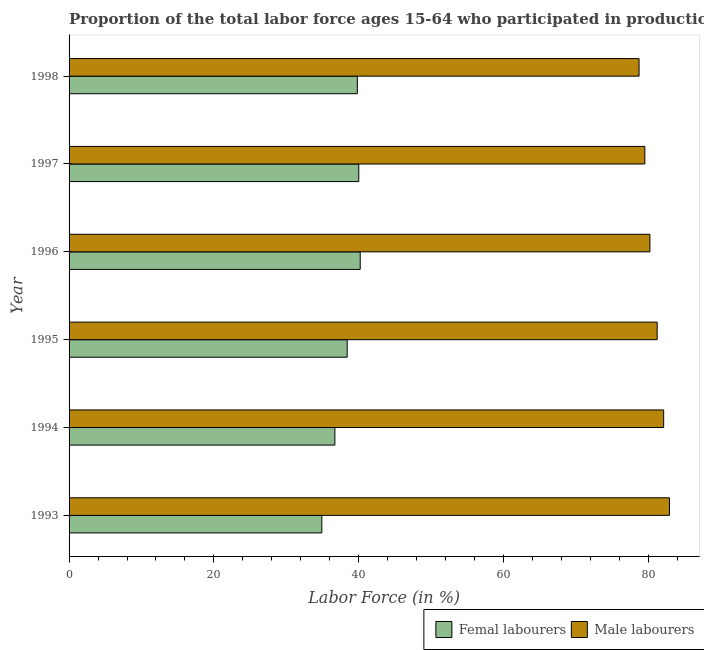How many groups of bars are there?
Your response must be concise. 6. Are the number of bars per tick equal to the number of legend labels?
Offer a very short reply. Yes. Are the number of bars on each tick of the Y-axis equal?
Your answer should be very brief. Yes. How many bars are there on the 2nd tick from the top?
Offer a very short reply. 2. What is the percentage of female labor force in 1996?
Give a very brief answer. 40.2. Across all years, what is the maximum percentage of male labour force?
Offer a terse response. 82.9. Across all years, what is the minimum percentage of female labor force?
Keep it short and to the point. 34.9. In which year was the percentage of female labor force maximum?
Offer a terse response. 1996. What is the total percentage of female labor force in the graph?
Ensure brevity in your answer.  230. What is the difference between the percentage of female labor force in 1994 and that in 1997?
Make the answer very short. -3.3. What is the difference between the percentage of female labor force in 1998 and the percentage of male labour force in 1995?
Provide a short and direct response. -41.4. What is the average percentage of male labour force per year?
Make the answer very short. 80.77. In the year 1997, what is the difference between the percentage of male labour force and percentage of female labor force?
Ensure brevity in your answer.  39.5. In how many years, is the percentage of female labor force greater than 72 %?
Ensure brevity in your answer.  0. What is the ratio of the percentage of female labor force in 1993 to that in 1996?
Your answer should be very brief. 0.87. What is the difference between the highest and the lowest percentage of female labor force?
Your answer should be compact. 5.3. In how many years, is the percentage of female labor force greater than the average percentage of female labor force taken over all years?
Your response must be concise. 4. Is the sum of the percentage of male labour force in 1997 and 1998 greater than the maximum percentage of female labor force across all years?
Provide a short and direct response. Yes. What does the 2nd bar from the top in 1998 represents?
Provide a short and direct response. Femal labourers. What does the 2nd bar from the bottom in 1997 represents?
Provide a short and direct response. Male labourers. How many years are there in the graph?
Offer a very short reply. 6. What is the difference between two consecutive major ticks on the X-axis?
Your response must be concise. 20. Are the values on the major ticks of X-axis written in scientific E-notation?
Ensure brevity in your answer.  No. What is the title of the graph?
Offer a terse response. Proportion of the total labor force ages 15-64 who participated in production in Fiji. What is the label or title of the X-axis?
Your answer should be compact. Labor Force (in %). What is the label or title of the Y-axis?
Provide a succinct answer. Year. What is the Labor Force (in %) of Femal labourers in 1993?
Keep it short and to the point. 34.9. What is the Labor Force (in %) of Male labourers in 1993?
Provide a succinct answer. 82.9. What is the Labor Force (in %) of Femal labourers in 1994?
Your response must be concise. 36.7. What is the Labor Force (in %) of Male labourers in 1994?
Your response must be concise. 82.1. What is the Labor Force (in %) in Femal labourers in 1995?
Provide a short and direct response. 38.4. What is the Labor Force (in %) in Male labourers in 1995?
Your answer should be compact. 81.2. What is the Labor Force (in %) of Femal labourers in 1996?
Ensure brevity in your answer.  40.2. What is the Labor Force (in %) in Male labourers in 1996?
Provide a short and direct response. 80.2. What is the Labor Force (in %) of Male labourers in 1997?
Make the answer very short. 79.5. What is the Labor Force (in %) of Femal labourers in 1998?
Your answer should be very brief. 39.8. What is the Labor Force (in %) of Male labourers in 1998?
Your answer should be compact. 78.7. Across all years, what is the maximum Labor Force (in %) in Femal labourers?
Your answer should be very brief. 40.2. Across all years, what is the maximum Labor Force (in %) in Male labourers?
Provide a succinct answer. 82.9. Across all years, what is the minimum Labor Force (in %) of Femal labourers?
Keep it short and to the point. 34.9. Across all years, what is the minimum Labor Force (in %) in Male labourers?
Provide a short and direct response. 78.7. What is the total Labor Force (in %) of Femal labourers in the graph?
Make the answer very short. 230. What is the total Labor Force (in %) in Male labourers in the graph?
Offer a terse response. 484.6. What is the difference between the Labor Force (in %) of Femal labourers in 1993 and that in 1994?
Your answer should be compact. -1.8. What is the difference between the Labor Force (in %) in Male labourers in 1993 and that in 1994?
Keep it short and to the point. 0.8. What is the difference between the Labor Force (in %) of Femal labourers in 1993 and that in 1995?
Offer a very short reply. -3.5. What is the difference between the Labor Force (in %) in Femal labourers in 1993 and that in 1997?
Provide a succinct answer. -5.1. What is the difference between the Labor Force (in %) in Femal labourers in 1993 and that in 1998?
Your answer should be compact. -4.9. What is the difference between the Labor Force (in %) of Male labourers in 1994 and that in 1995?
Keep it short and to the point. 0.9. What is the difference between the Labor Force (in %) in Femal labourers in 1994 and that in 1996?
Ensure brevity in your answer.  -3.5. What is the difference between the Labor Force (in %) in Male labourers in 1994 and that in 1996?
Your answer should be compact. 1.9. What is the difference between the Labor Force (in %) of Femal labourers in 1994 and that in 1997?
Make the answer very short. -3.3. What is the difference between the Labor Force (in %) of Femal labourers in 1994 and that in 1998?
Offer a very short reply. -3.1. What is the difference between the Labor Force (in %) in Male labourers in 1994 and that in 1998?
Give a very brief answer. 3.4. What is the difference between the Labor Force (in %) in Male labourers in 1995 and that in 1996?
Your answer should be compact. 1. What is the difference between the Labor Force (in %) of Femal labourers in 1995 and that in 1997?
Give a very brief answer. -1.6. What is the difference between the Labor Force (in %) of Femal labourers in 1995 and that in 1998?
Your response must be concise. -1.4. What is the difference between the Labor Force (in %) in Male labourers in 1995 and that in 1998?
Offer a terse response. 2.5. What is the difference between the Labor Force (in %) of Femal labourers in 1996 and that in 1998?
Provide a short and direct response. 0.4. What is the difference between the Labor Force (in %) of Male labourers in 1996 and that in 1998?
Offer a terse response. 1.5. What is the difference between the Labor Force (in %) in Male labourers in 1997 and that in 1998?
Your response must be concise. 0.8. What is the difference between the Labor Force (in %) of Femal labourers in 1993 and the Labor Force (in %) of Male labourers in 1994?
Keep it short and to the point. -47.2. What is the difference between the Labor Force (in %) of Femal labourers in 1993 and the Labor Force (in %) of Male labourers in 1995?
Your answer should be very brief. -46.3. What is the difference between the Labor Force (in %) in Femal labourers in 1993 and the Labor Force (in %) in Male labourers in 1996?
Make the answer very short. -45.3. What is the difference between the Labor Force (in %) of Femal labourers in 1993 and the Labor Force (in %) of Male labourers in 1997?
Your answer should be very brief. -44.6. What is the difference between the Labor Force (in %) in Femal labourers in 1993 and the Labor Force (in %) in Male labourers in 1998?
Provide a short and direct response. -43.8. What is the difference between the Labor Force (in %) of Femal labourers in 1994 and the Labor Force (in %) of Male labourers in 1995?
Offer a terse response. -44.5. What is the difference between the Labor Force (in %) of Femal labourers in 1994 and the Labor Force (in %) of Male labourers in 1996?
Provide a succinct answer. -43.5. What is the difference between the Labor Force (in %) of Femal labourers in 1994 and the Labor Force (in %) of Male labourers in 1997?
Provide a short and direct response. -42.8. What is the difference between the Labor Force (in %) of Femal labourers in 1994 and the Labor Force (in %) of Male labourers in 1998?
Keep it short and to the point. -42. What is the difference between the Labor Force (in %) in Femal labourers in 1995 and the Labor Force (in %) in Male labourers in 1996?
Provide a succinct answer. -41.8. What is the difference between the Labor Force (in %) in Femal labourers in 1995 and the Labor Force (in %) in Male labourers in 1997?
Give a very brief answer. -41.1. What is the difference between the Labor Force (in %) of Femal labourers in 1995 and the Labor Force (in %) of Male labourers in 1998?
Provide a succinct answer. -40.3. What is the difference between the Labor Force (in %) in Femal labourers in 1996 and the Labor Force (in %) in Male labourers in 1997?
Provide a short and direct response. -39.3. What is the difference between the Labor Force (in %) in Femal labourers in 1996 and the Labor Force (in %) in Male labourers in 1998?
Give a very brief answer. -38.5. What is the difference between the Labor Force (in %) in Femal labourers in 1997 and the Labor Force (in %) in Male labourers in 1998?
Your answer should be compact. -38.7. What is the average Labor Force (in %) in Femal labourers per year?
Offer a terse response. 38.33. What is the average Labor Force (in %) in Male labourers per year?
Keep it short and to the point. 80.77. In the year 1993, what is the difference between the Labor Force (in %) of Femal labourers and Labor Force (in %) of Male labourers?
Provide a succinct answer. -48. In the year 1994, what is the difference between the Labor Force (in %) of Femal labourers and Labor Force (in %) of Male labourers?
Ensure brevity in your answer.  -45.4. In the year 1995, what is the difference between the Labor Force (in %) in Femal labourers and Labor Force (in %) in Male labourers?
Offer a very short reply. -42.8. In the year 1996, what is the difference between the Labor Force (in %) of Femal labourers and Labor Force (in %) of Male labourers?
Your response must be concise. -40. In the year 1997, what is the difference between the Labor Force (in %) of Femal labourers and Labor Force (in %) of Male labourers?
Offer a terse response. -39.5. In the year 1998, what is the difference between the Labor Force (in %) of Femal labourers and Labor Force (in %) of Male labourers?
Provide a short and direct response. -38.9. What is the ratio of the Labor Force (in %) of Femal labourers in 1993 to that in 1994?
Ensure brevity in your answer.  0.95. What is the ratio of the Labor Force (in %) of Male labourers in 1993 to that in 1994?
Ensure brevity in your answer.  1.01. What is the ratio of the Labor Force (in %) of Femal labourers in 1993 to that in 1995?
Your response must be concise. 0.91. What is the ratio of the Labor Force (in %) in Male labourers in 1993 to that in 1995?
Give a very brief answer. 1.02. What is the ratio of the Labor Force (in %) in Femal labourers in 1993 to that in 1996?
Provide a short and direct response. 0.87. What is the ratio of the Labor Force (in %) of Male labourers in 1993 to that in 1996?
Your answer should be very brief. 1.03. What is the ratio of the Labor Force (in %) of Femal labourers in 1993 to that in 1997?
Give a very brief answer. 0.87. What is the ratio of the Labor Force (in %) in Male labourers in 1993 to that in 1997?
Provide a short and direct response. 1.04. What is the ratio of the Labor Force (in %) of Femal labourers in 1993 to that in 1998?
Provide a short and direct response. 0.88. What is the ratio of the Labor Force (in %) of Male labourers in 1993 to that in 1998?
Your response must be concise. 1.05. What is the ratio of the Labor Force (in %) of Femal labourers in 1994 to that in 1995?
Your answer should be very brief. 0.96. What is the ratio of the Labor Force (in %) in Male labourers in 1994 to that in 1995?
Provide a succinct answer. 1.01. What is the ratio of the Labor Force (in %) in Femal labourers in 1994 to that in 1996?
Your answer should be compact. 0.91. What is the ratio of the Labor Force (in %) in Male labourers in 1994 to that in 1996?
Give a very brief answer. 1.02. What is the ratio of the Labor Force (in %) in Femal labourers in 1994 to that in 1997?
Your answer should be compact. 0.92. What is the ratio of the Labor Force (in %) in Male labourers in 1994 to that in 1997?
Offer a terse response. 1.03. What is the ratio of the Labor Force (in %) of Femal labourers in 1994 to that in 1998?
Offer a terse response. 0.92. What is the ratio of the Labor Force (in %) of Male labourers in 1994 to that in 1998?
Give a very brief answer. 1.04. What is the ratio of the Labor Force (in %) in Femal labourers in 1995 to that in 1996?
Offer a terse response. 0.96. What is the ratio of the Labor Force (in %) of Male labourers in 1995 to that in 1996?
Your answer should be compact. 1.01. What is the ratio of the Labor Force (in %) of Femal labourers in 1995 to that in 1997?
Provide a short and direct response. 0.96. What is the ratio of the Labor Force (in %) of Male labourers in 1995 to that in 1997?
Keep it short and to the point. 1.02. What is the ratio of the Labor Force (in %) in Femal labourers in 1995 to that in 1998?
Offer a terse response. 0.96. What is the ratio of the Labor Force (in %) in Male labourers in 1995 to that in 1998?
Provide a short and direct response. 1.03. What is the ratio of the Labor Force (in %) in Male labourers in 1996 to that in 1997?
Provide a succinct answer. 1.01. What is the ratio of the Labor Force (in %) of Male labourers in 1996 to that in 1998?
Make the answer very short. 1.02. What is the ratio of the Labor Force (in %) of Femal labourers in 1997 to that in 1998?
Ensure brevity in your answer.  1. What is the ratio of the Labor Force (in %) of Male labourers in 1997 to that in 1998?
Make the answer very short. 1.01. What is the difference between the highest and the second highest Labor Force (in %) of Femal labourers?
Make the answer very short. 0.2. What is the difference between the highest and the lowest Labor Force (in %) in Femal labourers?
Make the answer very short. 5.3. 